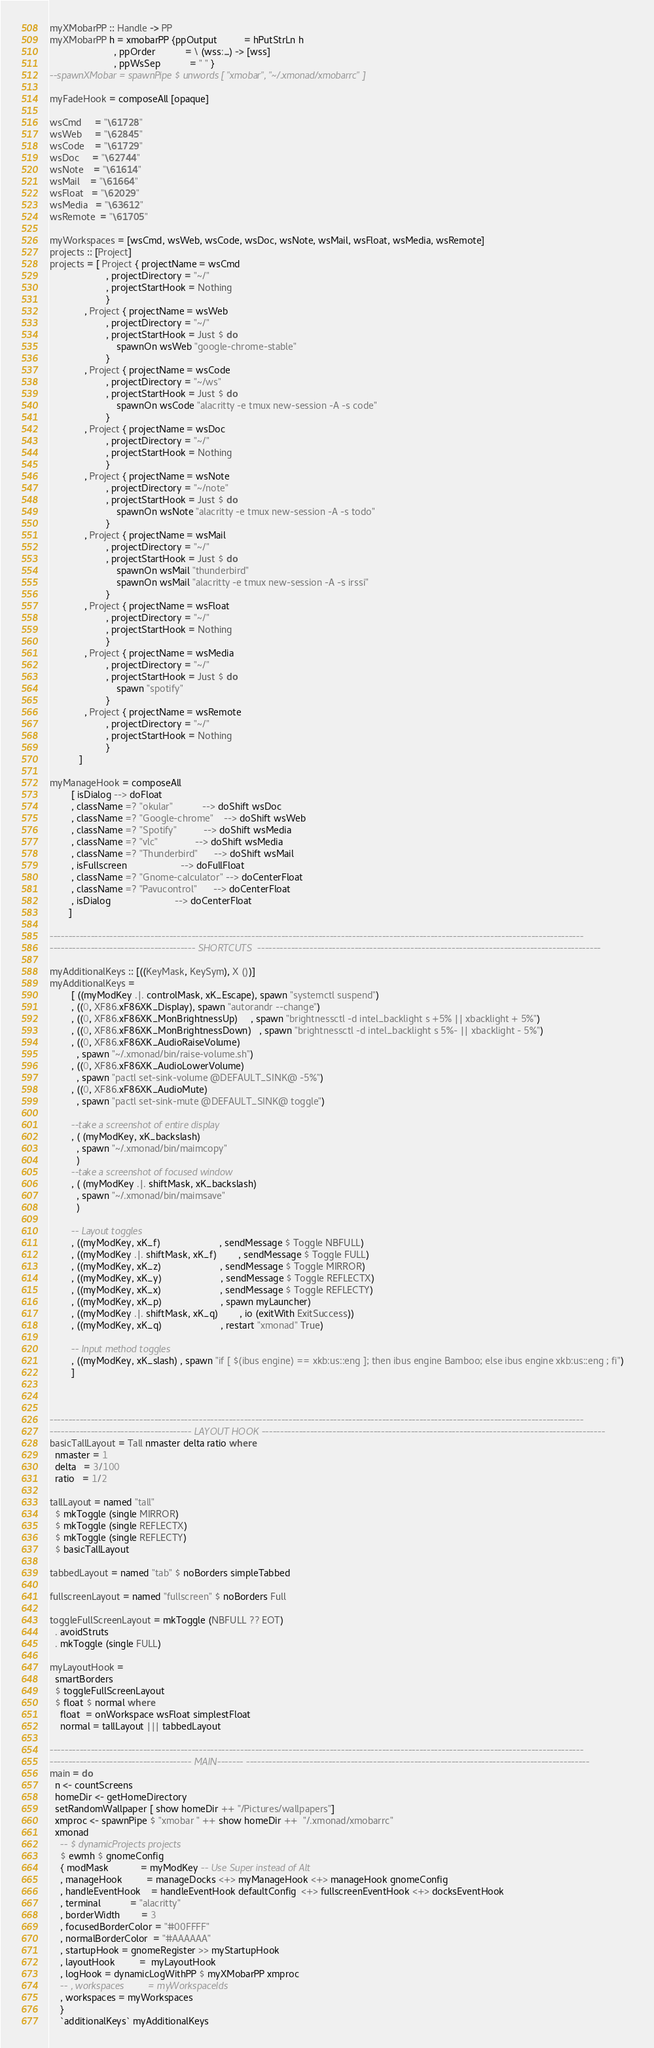<code> <loc_0><loc_0><loc_500><loc_500><_Haskell_>myXMobarPP :: Handle -> PP
myXMobarPP h = xmobarPP {ppOutput          = hPutStrLn h
                        , ppOrder           = \ (wss:_) -> [wss]
                        , ppWsSep           = " " }
--spawnXMobar = spawnPipe $ unwords [ "xmobar", "~/.xmonad/xmobarrc" ]

myFadeHook = composeAll [opaque]

wsCmd     = "\61728"
wsWeb     = "\62845"
wsCode    = "\61729"
wsDoc     = "\62744"
wsNote    = "\61614"
wsMail    = "\61664"
wsFloat   = "\62029"
wsMedia   = "\63612"
wsRemote  = "\61705"

myWorkspaces = [wsCmd, wsWeb, wsCode, wsDoc, wsNote, wsMail, wsFloat, wsMedia, wsRemote]
projects :: [Project]
projects = [ Project { projectName = wsCmd
                     , projectDirectory = "~/"
                     , projectStartHook = Nothing
                     }
             , Project { projectName = wsWeb
                     , projectDirectory = "~/"
                     , projectStartHook = Just $ do
                         spawnOn wsWeb "google-chrome-stable"
                     }
             , Project { projectName = wsCode
                     , projectDirectory = "~/ws"
                     , projectStartHook = Just $ do
                         spawnOn wsCode "alacritty -e tmux new-session -A -s code"
                     }
             , Project { projectName = wsDoc
                     , projectDirectory = "~/"
                     , projectStartHook = Nothing
                     }
             , Project { projectName = wsNote
                     , projectDirectory = "~/note"
                     , projectStartHook = Just $ do
                         spawnOn wsNote "alacritty -e tmux new-session -A -s todo"
                     }
             , Project { projectName = wsMail
                     , projectDirectory = "~/"
                     , projectStartHook = Just $ do
                         spawnOn wsMail "thunderbird"
                         spawnOn wsMail "alacritty -e tmux new-session -A -s irssi"
                     }
             , Project { projectName = wsFloat
                     , projectDirectory = "~/"
                     , projectStartHook = Nothing
                     }
             , Project { projectName = wsMedia
                     , projectDirectory = "~/"
                     , projectStartHook = Just $ do
                         spawn "spotify"
                     }
             , Project { projectName = wsRemote
                     , projectDirectory = "~/"
                     , projectStartHook = Nothing
                     }
           ]

myManageHook = composeAll
        [ isDialog --> doFloat
        , className =? "okular"           --> doShift wsDoc
        , className =? "Google-chrome"    --> doShift wsWeb
        , className =? "Spotify"          --> doShift wsMedia
        , className =? "vlc"              --> doShift wsMedia
        , className =? "Thunderbird"      --> doShift wsMail
        , isFullscreen                    --> doFullFloat
        , className =? "Gnome-calculator" --> doCenterFloat
        , className =? "Pavucontrol"      --> doCenterFloat
        , isDialog                        --> doCenterFloat
       ]

-----------------------------------------------------------------------------------------------------------------------------------------------
--------------------------------------- SHORTCUTS  --------------------------------------------------------------------------------------------

myAdditionalKeys :: [((KeyMask, KeySym), X ())]
myAdditionalKeys =
        [ ((myModKey .|. controlMask, xK_Escape), spawn "systemctl suspend")
        , ((0, XF86.xF86XK_Display), spawn "autorandr --change")
        , ((0, XF86.xF86XK_MonBrightnessUp)     , spawn "brightnessctl -d intel_backlight s +5% || xbacklight + 5%")
        , ((0, XF86.xF86XK_MonBrightnessDown)   , spawn "brightnessctl -d intel_backlight s 5%- || xbacklight - 5%")
        , ((0, XF86.xF86XK_AudioRaiseVolume)
          , spawn "~/.xmonad/bin/raise-volume.sh")
        , ((0, XF86.xF86XK_AudioLowerVolume)
          , spawn "pactl set-sink-volume @DEFAULT_SINK@ -5%")
        , ((0, XF86.xF86XK_AudioMute)
          , spawn "pactl set-sink-mute @DEFAULT_SINK@ toggle")

        --take a screenshot of entire display
        , ( (myModKey, xK_backslash)
          , spawn "~/.xmonad/bin/maimcopy"
          )
        --take a screenshot of focused window
        , ( (myModKey .|. shiftMask, xK_backslash)
          , spawn "~/.xmonad/bin/maimsave"
          )

        -- Layout toggles
        , ((myModKey, xK_f)                      , sendMessage $ Toggle NBFULL)
        , ((myModKey .|. shiftMask, xK_f)        , sendMessage $ Toggle FULL)
        , ((myModKey, xK_z)                      , sendMessage $ Toggle MIRROR)
        , ((myModKey, xK_y)                      , sendMessage $ Toggle REFLECTX)
        , ((myModKey, xK_x)                      , sendMessage $ Toggle REFLECTY)
        , ((myModKey, xK_p)                      , spawn myLauncher)
        , ((myModKey .|. shiftMask, xK_q)        , io (exitWith ExitSuccess))
        , ((myModKey, xK_q)                      , restart "xmonad" True)

        -- Input method toggles
        , ((myModKey, xK_slash) , spawn "if [ $(ibus engine) == xkb:us::eng ]; then ibus engine Bamboo; else ibus engine xkb:us::eng ; fi")
        ]



-----------------------------------------------------------------------------------------------------------------------------------------------
-------------------------------------- LAYOUT HOOK --------------------------------------------------------------------------------------------
basicTallLayout = Tall nmaster delta ratio where
  nmaster = 1
  delta   = 3/100
  ratio   = 1/2

tallLayout = named "tall"
  $ mkToggle (single MIRROR)
  $ mkToggle (single REFLECTX)
  $ mkToggle (single REFLECTY)
  $ basicTallLayout

tabbedLayout = named "tab" $ noBorders simpleTabbed

fullscreenLayout = named "fullscreen" $ noBorders Full

toggleFullScreenLayout = mkToggle (NBFULL ?? EOT)
  . avoidStruts
  . mkToggle (single FULL)

myLayoutHook =
  smartBorders
  $ toggleFullScreenLayout
  $ float $ normal where
    float  = onWorkspace wsFloat simplestFloat
    normal = tallLayout ||| tabbedLayout

-----------------------------------------------------------------------------------------------------------------------------------------------
-------------------------------------- MAIN------- --------------------------------------------------------------------------------------------
main = do
  n <- countScreens
  homeDir <- getHomeDirectory
  setRandomWallpaper [ show homeDir ++ "/Pictures/wallpapers"]
  xmproc <- spawnPipe $ "xmobar " ++ show homeDir ++  "/.xmonad/xmobarrc"
  xmonad
    -- $ dynamicProjects projects
    $ ewmh $ gnomeConfig
    { modMask            = myModKey -- Use Super instead of Alt
    , manageHook         = manageDocks <+> myManageHook <+> manageHook gnomeConfig
    , handleEventHook    = handleEventHook defaultConfig  <+> fullscreenEventHook <+> docksEventHook
    , terminal           = "alacritty"
    , borderWidth        = 3
    , focusedBorderColor = "#00FFFF"
    , normalBorderColor  = "#AAAAAA"
    , startupHook = gnomeRegister >> myStartupHook
    , layoutHook         =  myLayoutHook
    , logHook = dynamicLogWithPP $ myXMobarPP xmproc
    -- , workspaces         = myWorkspaceIds
    , workspaces = myWorkspaces
    }
    `additionalKeys` myAdditionalKeys
</code> 